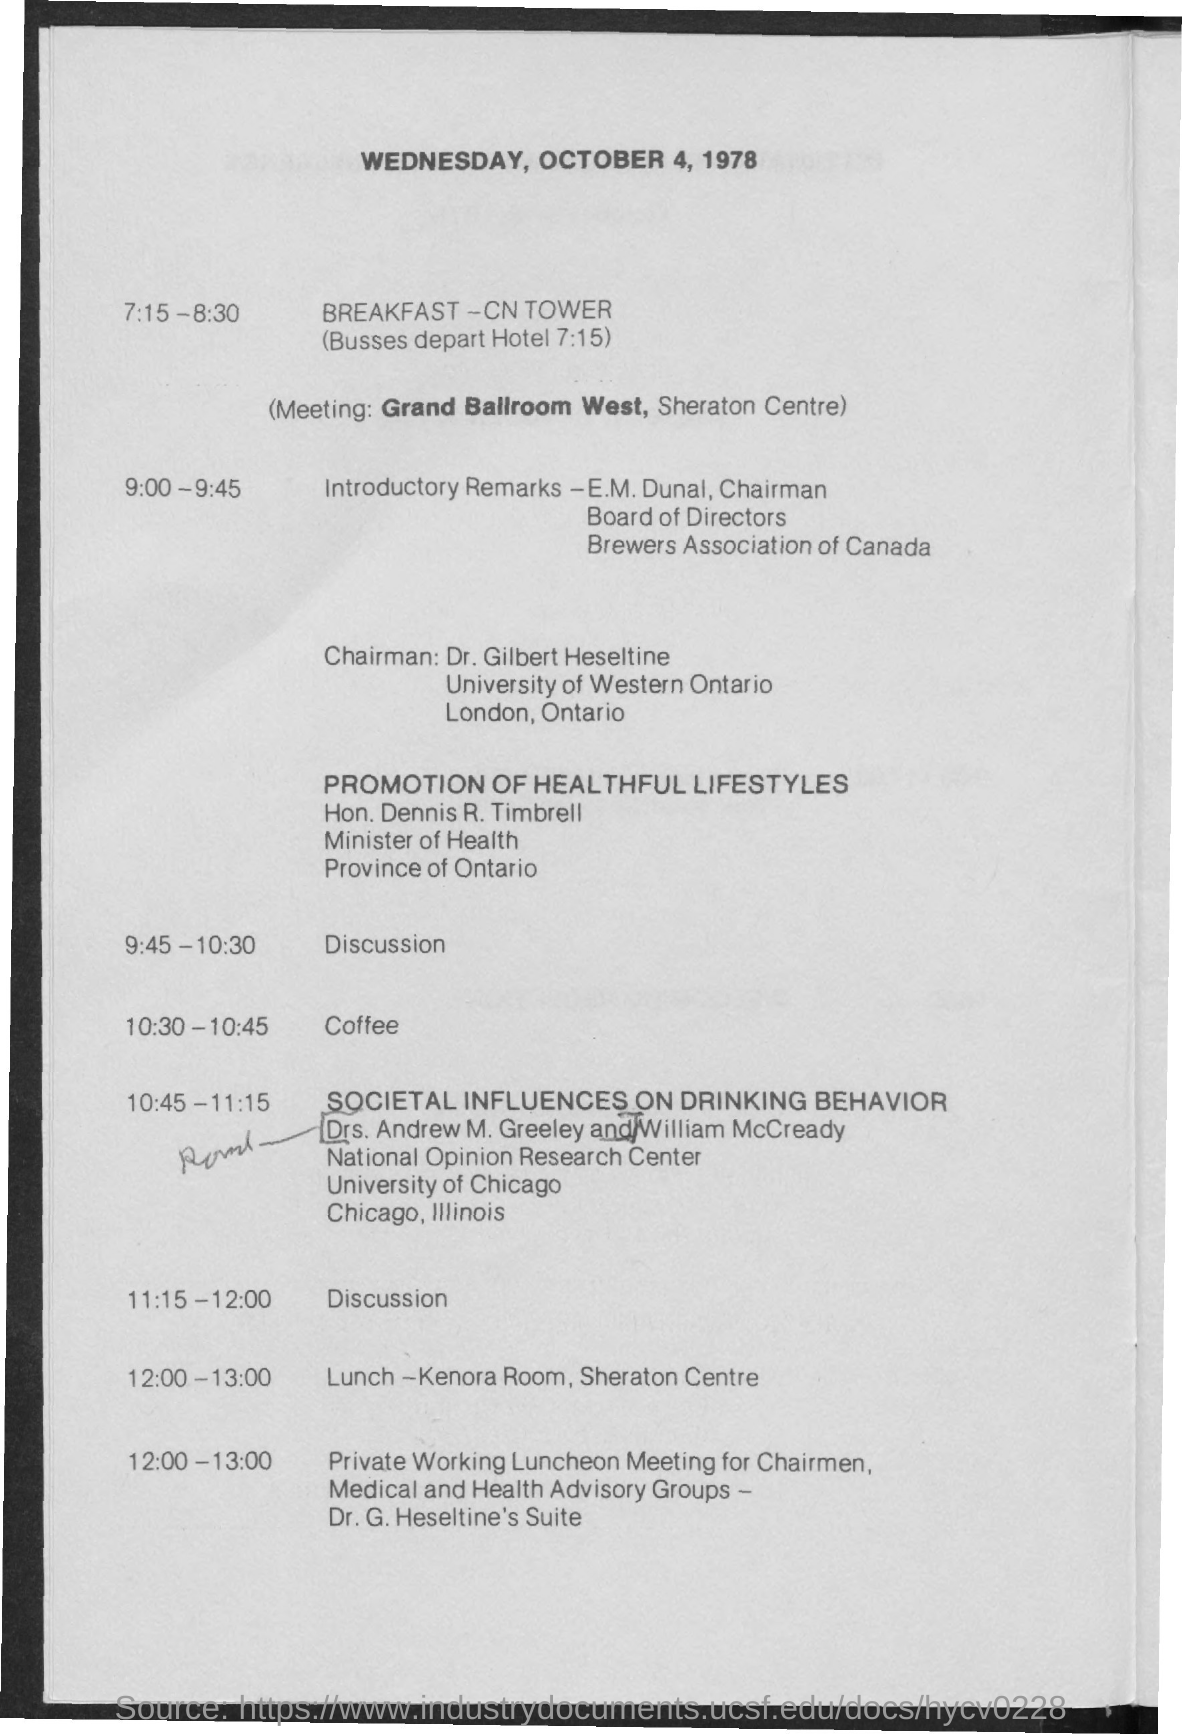What is the schedule at the time of 9:45 - 10:30 ?
Your response must be concise. Discussion. What is the schedule at the time of 10:30 - 10:45 ?
Your answer should be compact. Coffee. What is the schedule at the time of 11:15-12:00 ?
Ensure brevity in your answer.  Discussion. What is the schedule at the time of 12:00 - 13:00 ?
Make the answer very short. Lunch. Where is the meeting scheduled ?
Ensure brevity in your answer.  Grand ballroom west, sheraton centre. 